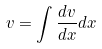Convert formula to latex. <formula><loc_0><loc_0><loc_500><loc_500>v = \int \frac { d v } { d x } d x</formula> 